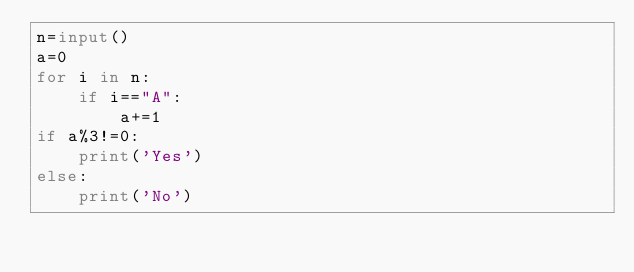Convert code to text. <code><loc_0><loc_0><loc_500><loc_500><_Python_>n=input()
a=0
for i in n:
    if i=="A":
        a+=1
if a%3!=0:
    print('Yes')
else:
    print('No')
</code> 